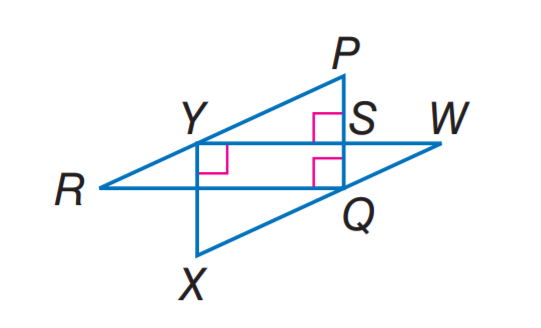Answer the mathemtical geometry problem and directly provide the correct option letter.
Question: If P R \parallel W X, W X = 10, X Y = 6, W Y = 8, R Y = 5, and P S = 3, find S Y.
Choices: A: 3 B: 4 C: 5 D: 6 B 